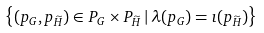Convert formula to latex. <formula><loc_0><loc_0><loc_500><loc_500>\left \{ ( p _ { G } , p _ { \widetilde { H } } ) \in P _ { G } \times P _ { \widetilde { H } } \, | \, \lambda ( p _ { G } ) = \imath ( p _ { \widetilde { H } } ) \right \}</formula> 